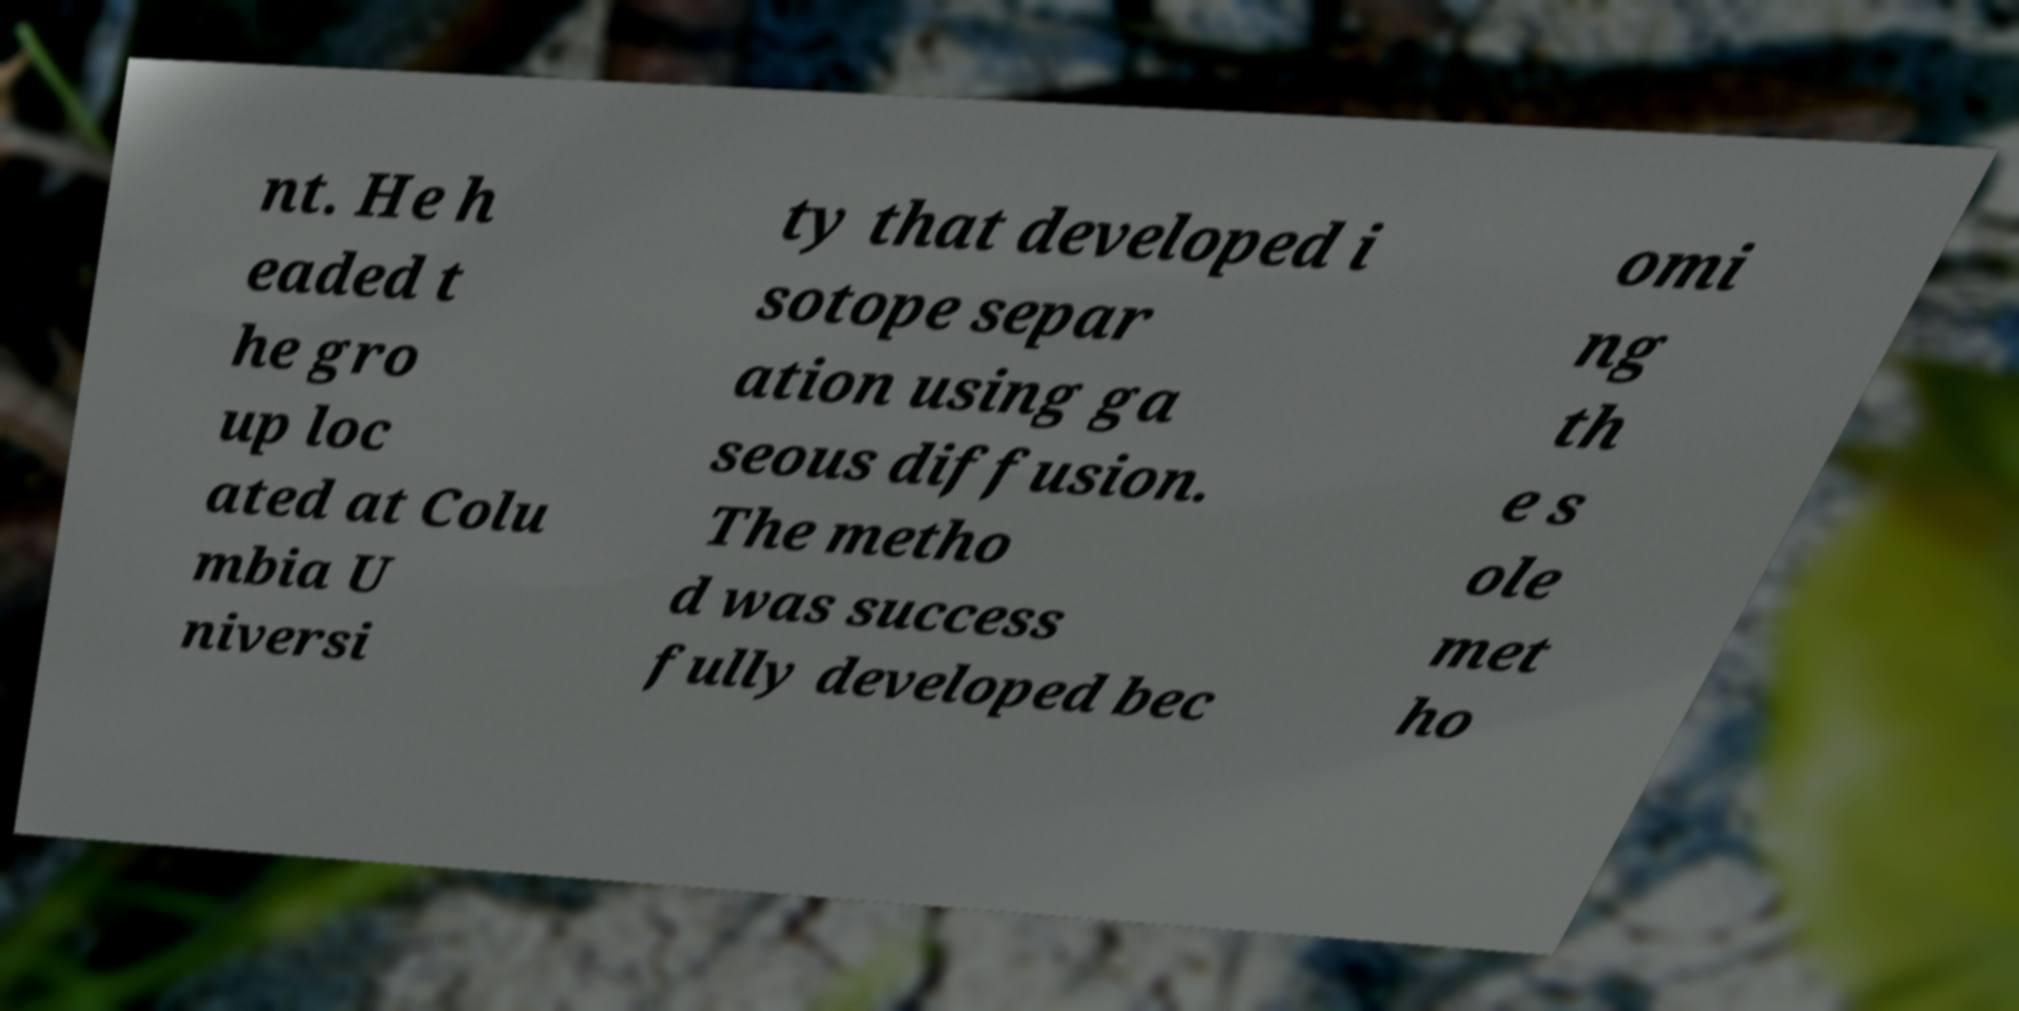Can you read and provide the text displayed in the image?This photo seems to have some interesting text. Can you extract and type it out for me? nt. He h eaded t he gro up loc ated at Colu mbia U niversi ty that developed i sotope separ ation using ga seous diffusion. The metho d was success fully developed bec omi ng th e s ole met ho 